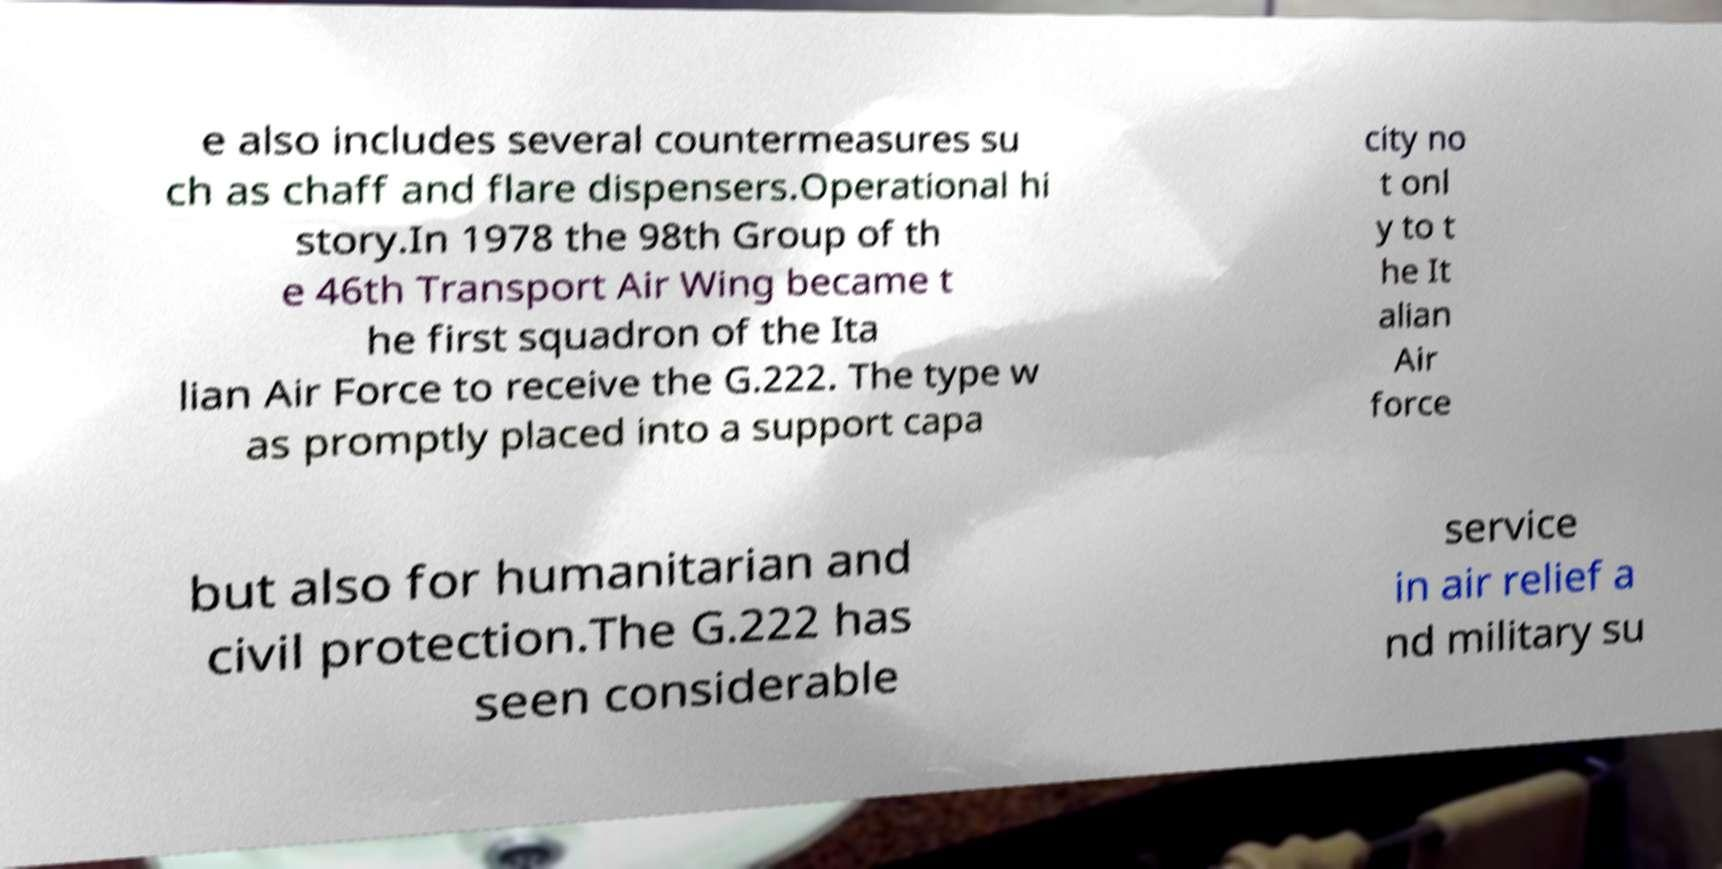Can you read and provide the text displayed in the image?This photo seems to have some interesting text. Can you extract and type it out for me? e also includes several countermeasures su ch as chaff and flare dispensers.Operational hi story.In 1978 the 98th Group of th e 46th Transport Air Wing became t he first squadron of the Ita lian Air Force to receive the G.222. The type w as promptly placed into a support capa city no t onl y to t he It alian Air force but also for humanitarian and civil protection.The G.222 has seen considerable service in air relief a nd military su 